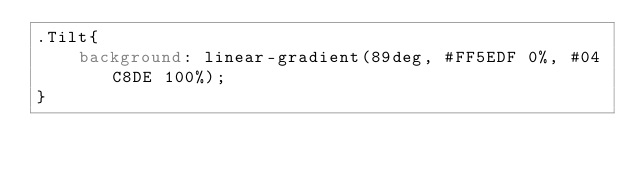<code> <loc_0><loc_0><loc_500><loc_500><_CSS_>.Tilt{
    background: linear-gradient(89deg, #FF5EDF 0%, #04C8DE 100%);
}</code> 